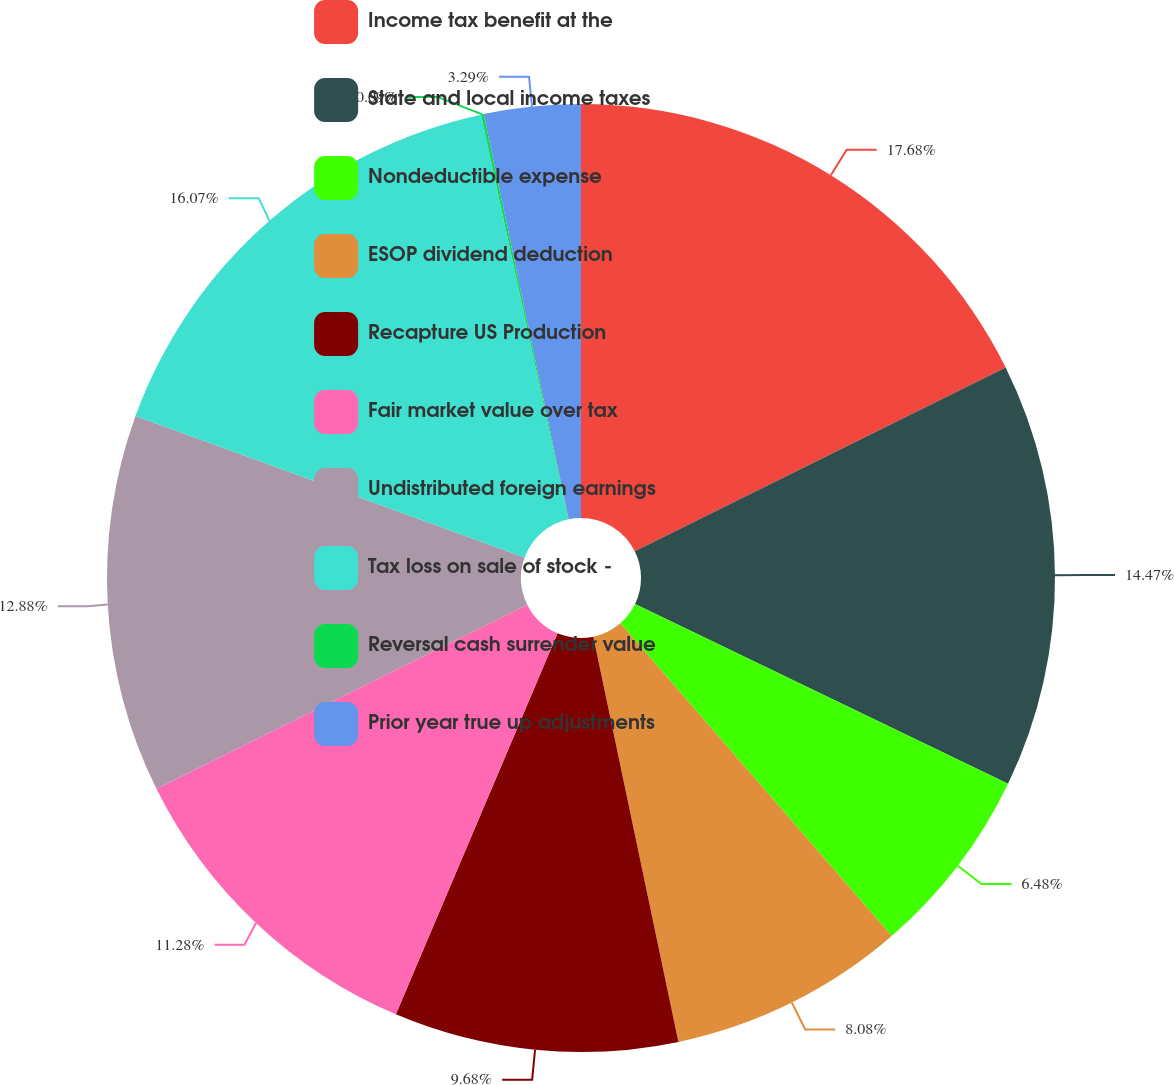<chart> <loc_0><loc_0><loc_500><loc_500><pie_chart><fcel>Income tax benefit at the<fcel>State and local income taxes<fcel>Nondeductible expense<fcel>ESOP dividend deduction<fcel>Recapture US Production<fcel>Fair market value over tax<fcel>Undistributed foreign earnings<fcel>Tax loss on sale of stock -<fcel>Reversal cash surrender value<fcel>Prior year true up adjustments<nl><fcel>17.67%<fcel>14.47%<fcel>6.48%<fcel>8.08%<fcel>9.68%<fcel>11.28%<fcel>12.88%<fcel>16.07%<fcel>0.09%<fcel>3.29%<nl></chart> 